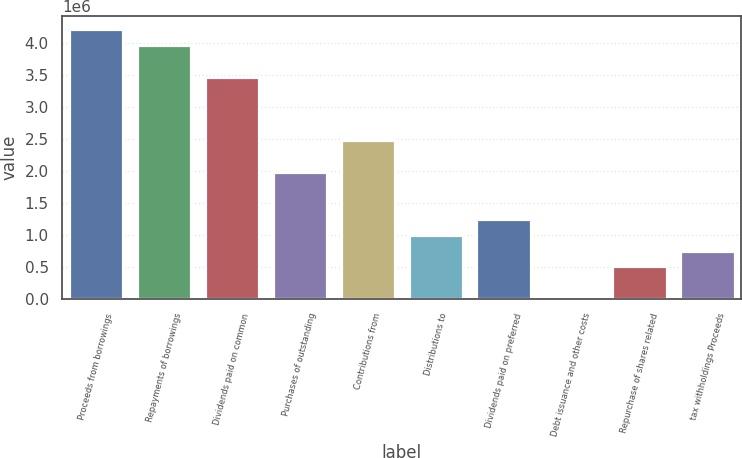Convert chart to OTSL. <chart><loc_0><loc_0><loc_500><loc_500><bar_chart><fcel>Proceeds from borrowings<fcel>Repayments of borrowings<fcel>Dividends paid on common<fcel>Purchases of outstanding<fcel>Contributions from<fcel>Distributions to<fcel>Dividends paid on preferred<fcel>Debt issuance and other costs<fcel>Repurchase of shares related<fcel>tax withholdings Proceeds<nl><fcel>4.20872e+06<fcel>3.96202e+06<fcel>3.46864e+06<fcel>1.9885e+06<fcel>2.48188e+06<fcel>1.00174e+06<fcel>1.24843e+06<fcel>14980<fcel>508361<fcel>755051<nl></chart> 